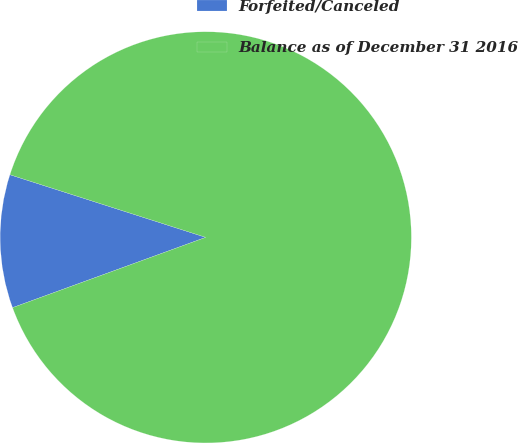<chart> <loc_0><loc_0><loc_500><loc_500><pie_chart><fcel>Forfeited/Canceled<fcel>Balance as of December 31 2016<nl><fcel>10.48%<fcel>89.52%<nl></chart> 